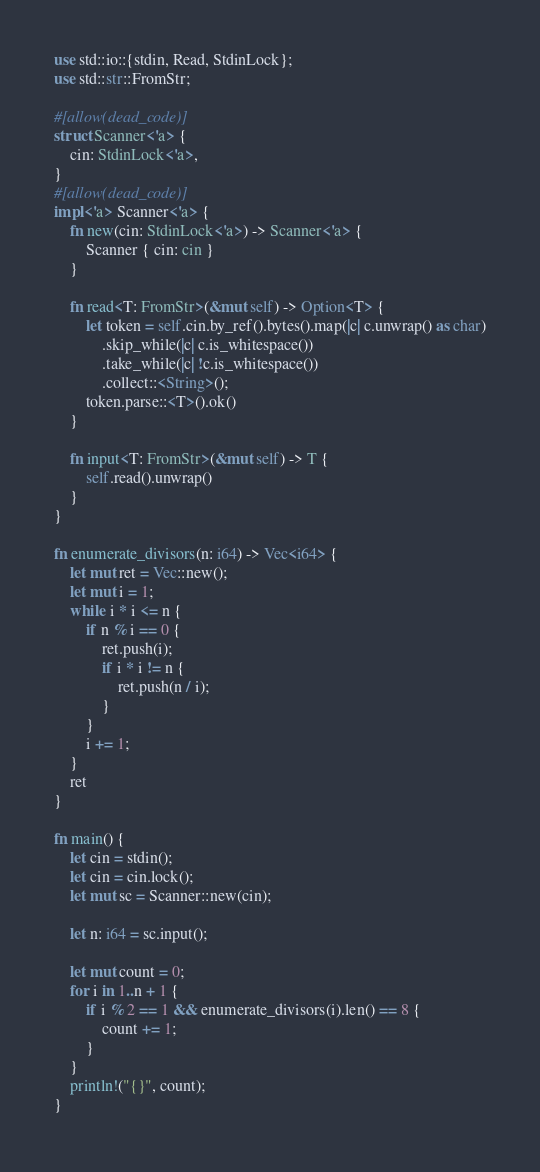<code> <loc_0><loc_0><loc_500><loc_500><_Rust_>use std::io::{stdin, Read, StdinLock};
use std::str::FromStr;

#[allow(dead_code)]
struct Scanner<'a> {
    cin: StdinLock<'a>,
}
#[allow(dead_code)]
impl<'a> Scanner<'a> {
    fn new(cin: StdinLock<'a>) -> Scanner<'a> {
        Scanner { cin: cin }
    }

    fn read<T: FromStr>(&mut self) -> Option<T> {
        let token = self.cin.by_ref().bytes().map(|c| c.unwrap() as char)
            .skip_while(|c| c.is_whitespace())
            .take_while(|c| !c.is_whitespace())
            .collect::<String>();
        token.parse::<T>().ok()
    }

    fn input<T: FromStr>(&mut self) -> T {
        self.read().unwrap()
    }
}

fn enumerate_divisors(n: i64) -> Vec<i64> {
    let mut ret = Vec::new();
    let mut i = 1;
    while i * i <= n {
        if n % i == 0 {
            ret.push(i);
            if i * i != n {
                ret.push(n / i);
            }
        }
        i += 1;
    }
    ret
}

fn main() {
    let cin = stdin();
    let cin = cin.lock();
    let mut sc = Scanner::new(cin);

    let n: i64 = sc.input();

    let mut count = 0;
    for i in 1..n + 1 {
        if i % 2 == 1 && enumerate_divisors(i).len() == 8 {
            count += 1;
        }
    }
    println!("{}", count);
}
</code> 